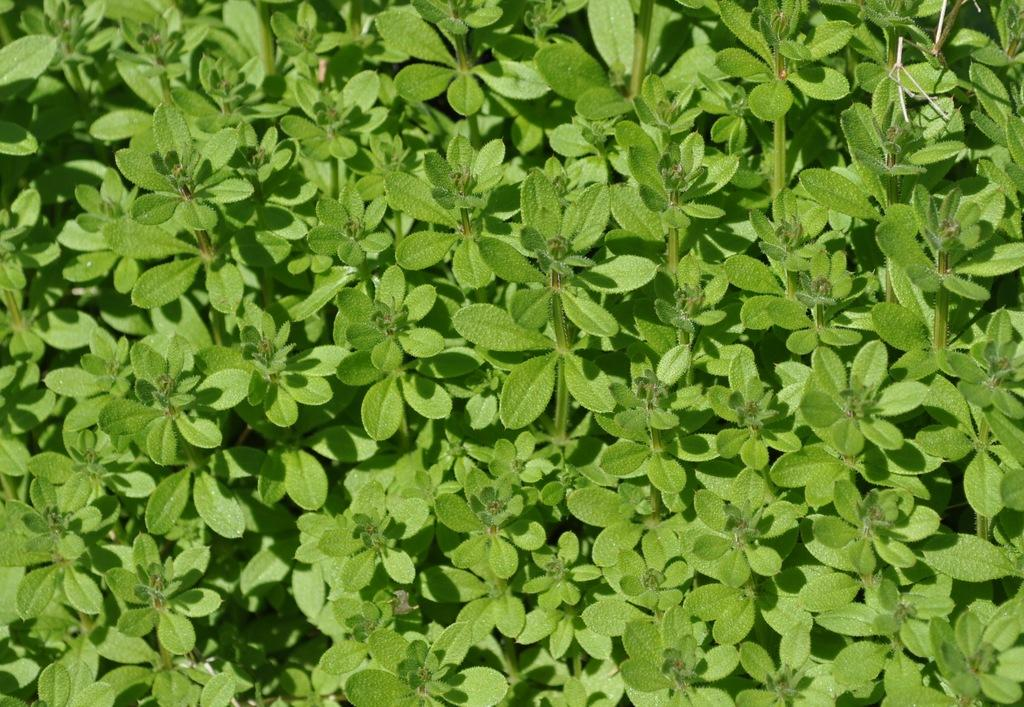What type of plants are visible in the image? There are herbs in the image. Can you describe the appearance of the herbs? The herbs may have leaves, stems, and flowers, but the specific appearance depends on the type of herbs. Are the herbs growing in a particular setting or arrangement? The facts provided do not specify the setting or arrangement of the herbs. What type of coaching advice can be seen in the image? There is no coaching advice present in the image, as it only features herbs. 